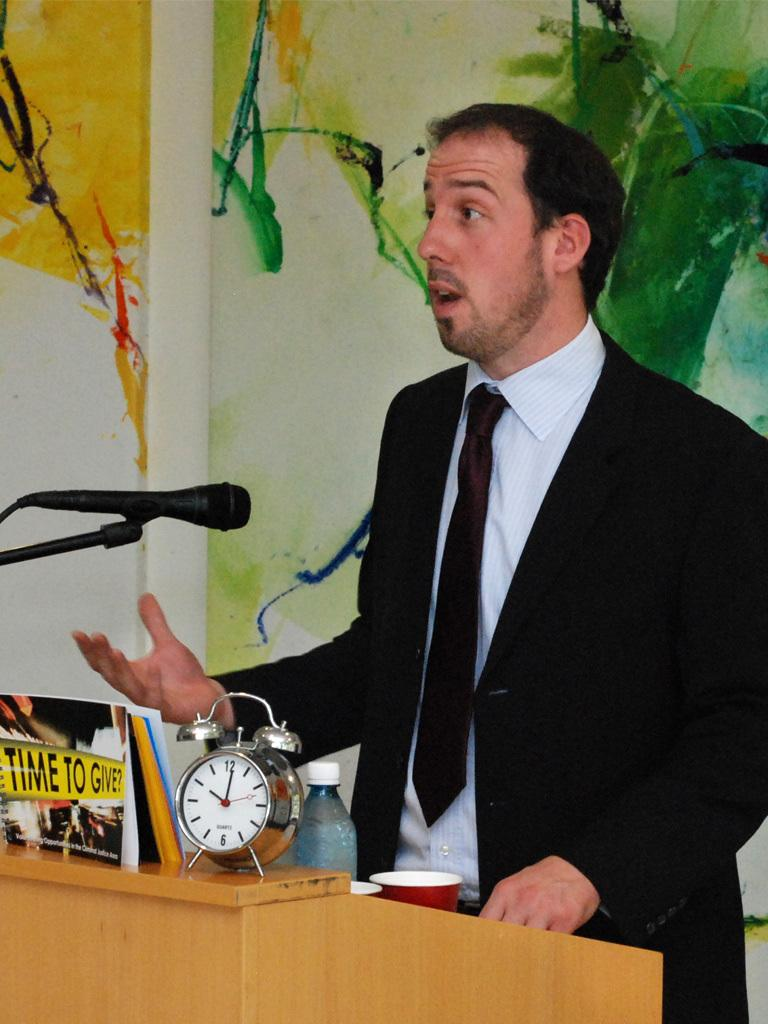<image>
Offer a succinct explanation of the picture presented. A book called Time To Give is sitting on a podium as a man speaks. 